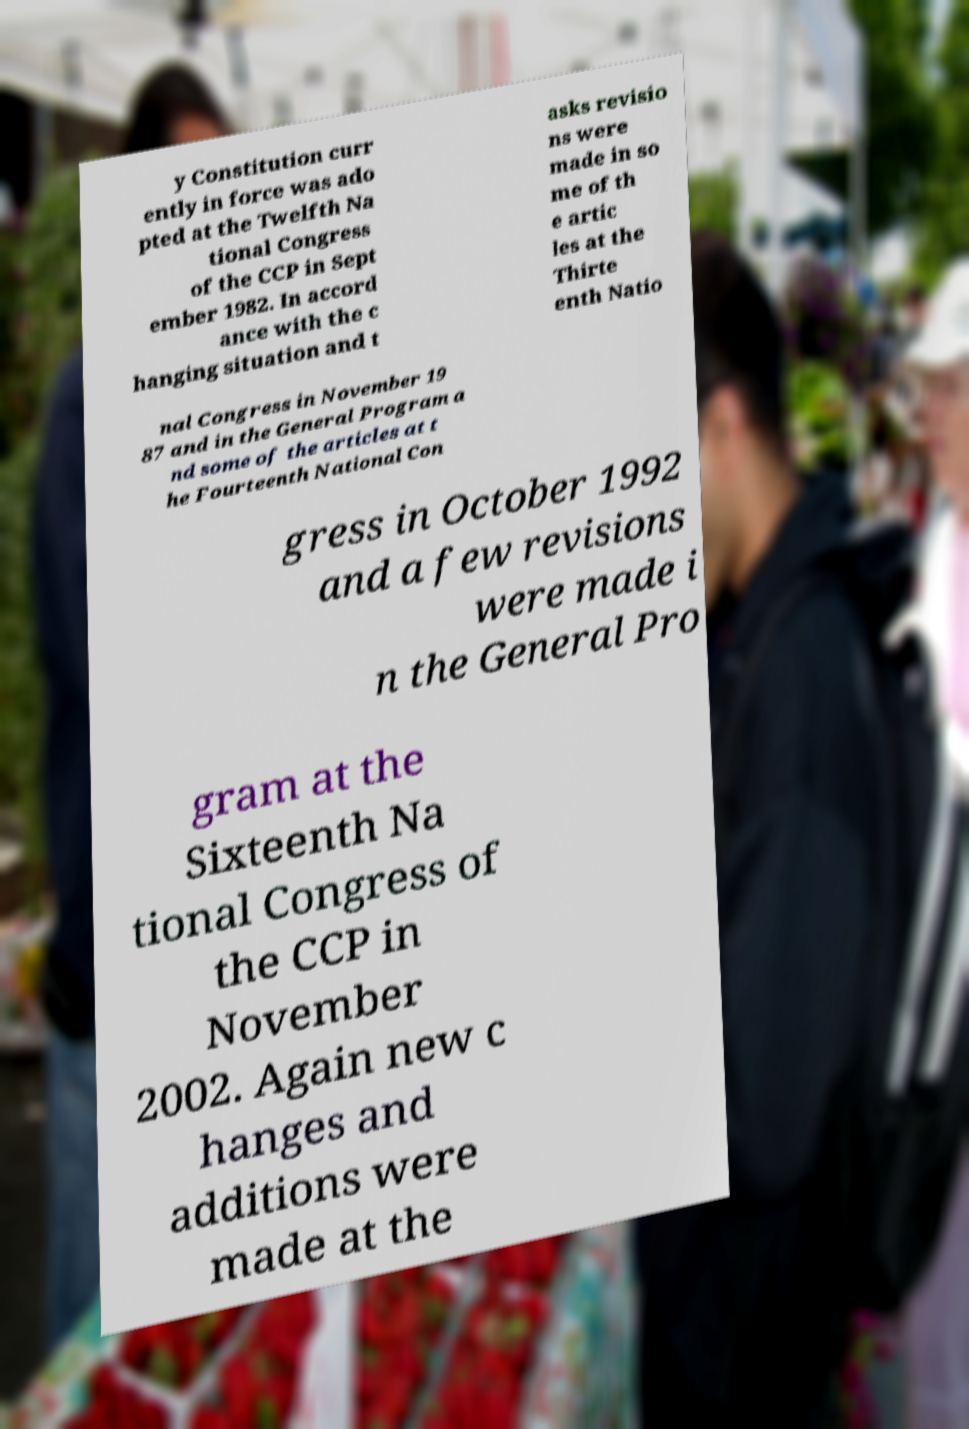Can you accurately transcribe the text from the provided image for me? y Constitution curr ently in force was ado pted at the Twelfth Na tional Congress of the CCP in Sept ember 1982. In accord ance with the c hanging situation and t asks revisio ns were made in so me of th e artic les at the Thirte enth Natio nal Congress in November 19 87 and in the General Program a nd some of the articles at t he Fourteenth National Con gress in October 1992 and a few revisions were made i n the General Pro gram at the Sixteenth Na tional Congress of the CCP in November 2002. Again new c hanges and additions were made at the 